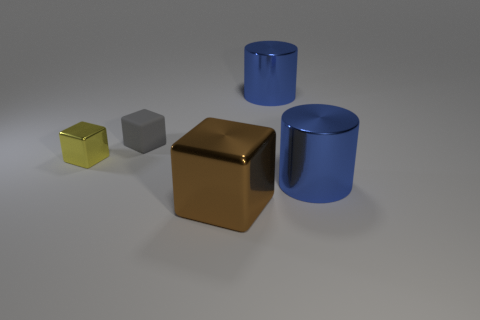Are these objects arranged in a random order? The objects appear to be deliberately arranged by size and color, creating an aesthetically pleasing gradient from left to right, which implies an intentional composition rather than a random placement. 